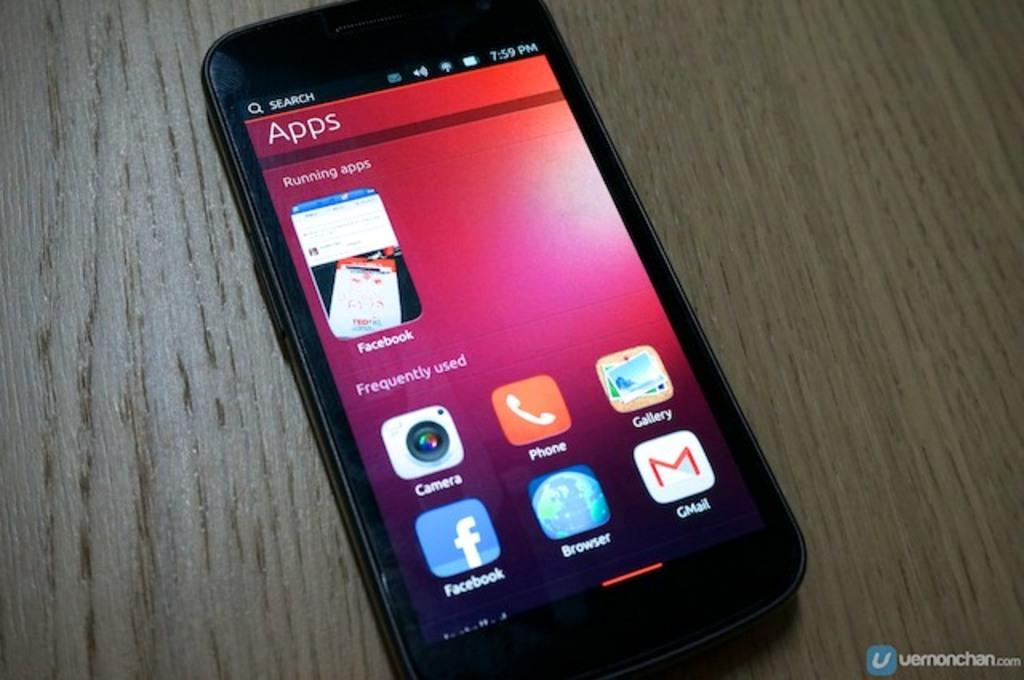<image>
Share a concise interpretation of the image provided. A smart phone on a wood grain surface shows a screen called "Apps" featuring Facebook. 